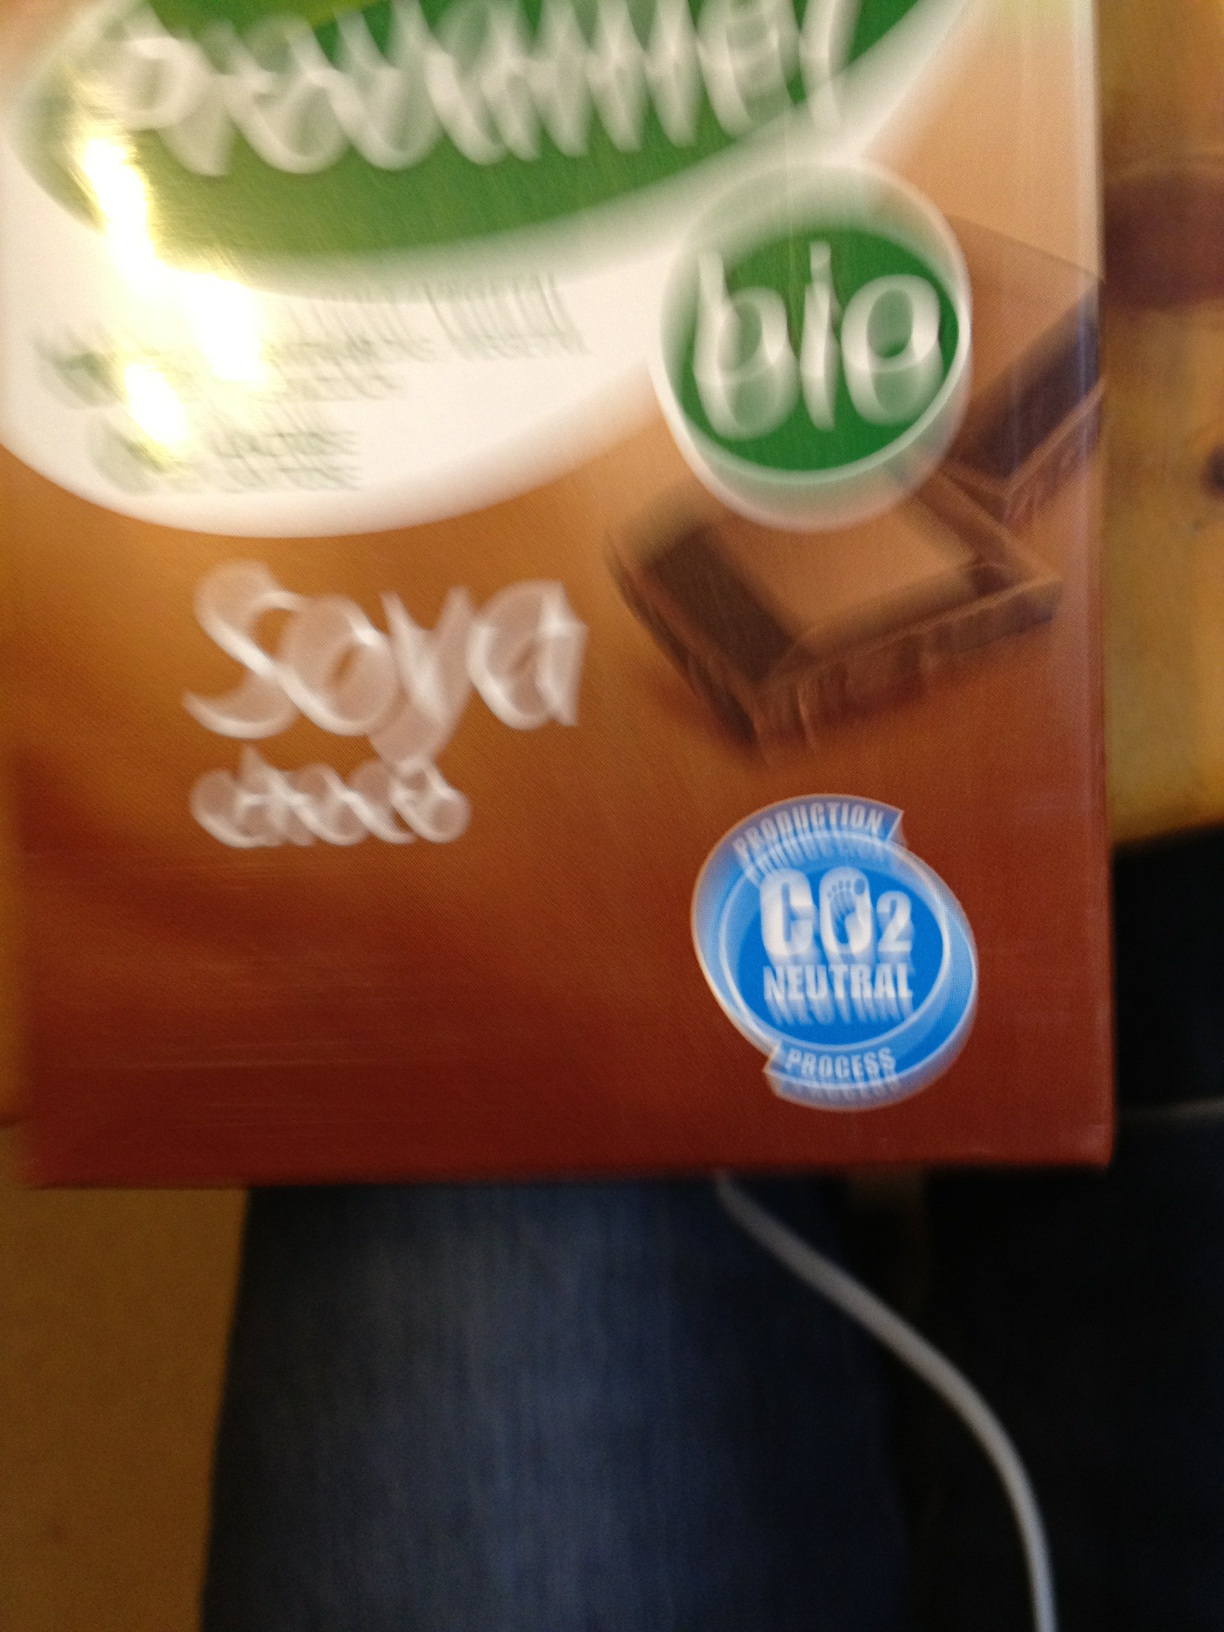Is there any indication that this product might be environmentally friendly based on the image? Yes, the packaging displays a 'CO2 neutral' certification, implying that the production of the product does not contribute net additional carbon dioxide to the atmosphere, which is an environmentally friendly feature. Does the 'bio' label add to its environmental appeal? Absolutely. The 'bio' label typically indicates that a product is made with organic ingredients, which require methodologies that are generally more sustainable and environmentally friendly than conventional practices. 